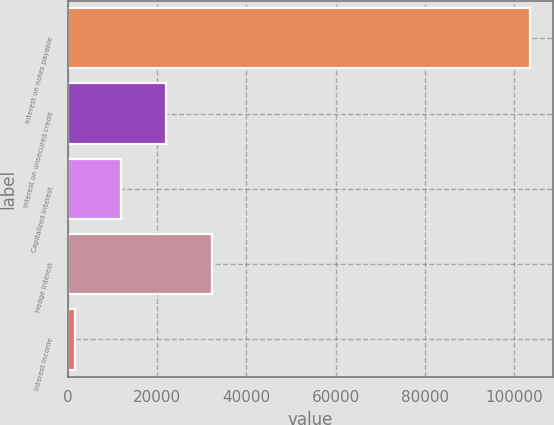Convert chart to OTSL. <chart><loc_0><loc_0><loc_500><loc_500><bar_chart><fcel>Interest on notes payable<fcel>Interest on unsecured credit<fcel>Capitalized interest<fcel>Hedge interest<fcel>Interest income<nl><fcel>103610<fcel>22062<fcel>11868.5<fcel>32255.5<fcel>1675<nl></chart> 